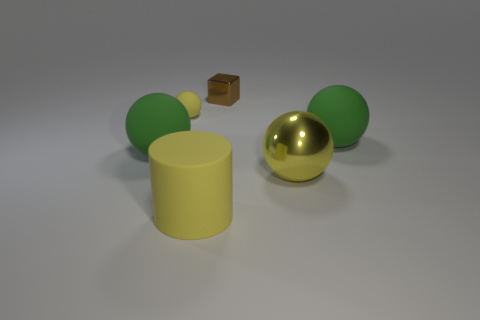The yellow object that is behind the big cylinder and to the left of the metal ball is made of what material?
Give a very brief answer. Rubber. What number of objects are behind the tiny brown metallic thing?
Keep it short and to the point. 0. Is the material of the large green ball on the left side of the small metallic object the same as the yellow ball that is on the left side of the small block?
Your response must be concise. Yes. What number of objects are rubber spheres that are right of the block or small cyan metal cylinders?
Your response must be concise. 1. Is the number of metallic balls in front of the large yellow cylinder less than the number of things left of the small cube?
Offer a very short reply. Yes. How many other objects are there of the same size as the yellow metallic object?
Offer a terse response. 3. Is the tiny brown block made of the same material as the yellow sphere in front of the tiny ball?
Make the answer very short. Yes. How many things are metal objects in front of the brown thing or big green balls in front of the small brown object?
Offer a terse response. 3. The small rubber object has what color?
Offer a very short reply. Yellow. Is the number of rubber things behind the tiny cube less than the number of big red cubes?
Your response must be concise. No. 